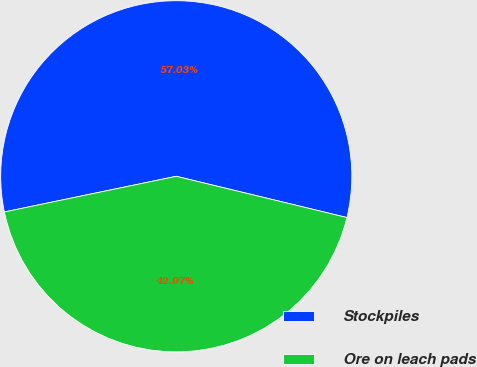Convert chart to OTSL. <chart><loc_0><loc_0><loc_500><loc_500><pie_chart><fcel>Stockpiles<fcel>Ore on leach pads<nl><fcel>57.03%<fcel>42.97%<nl></chart> 